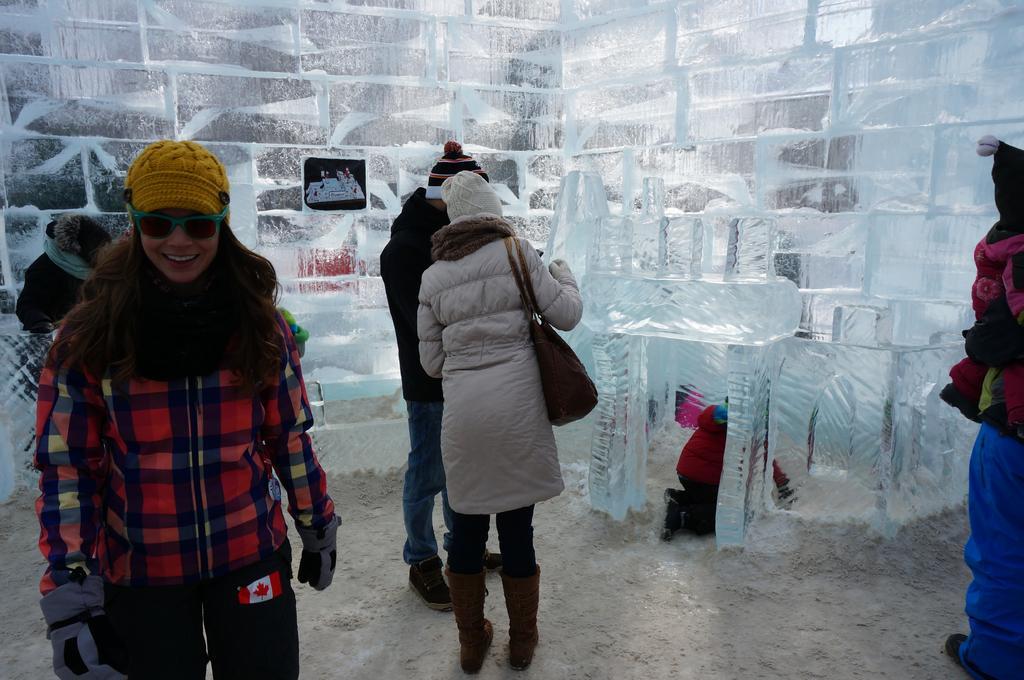How would you summarize this image in a sentence or two? Inside an ice room,there are few people visiting the construction and a kid is playing inside the small ice room and all the people are wearing jackets. 